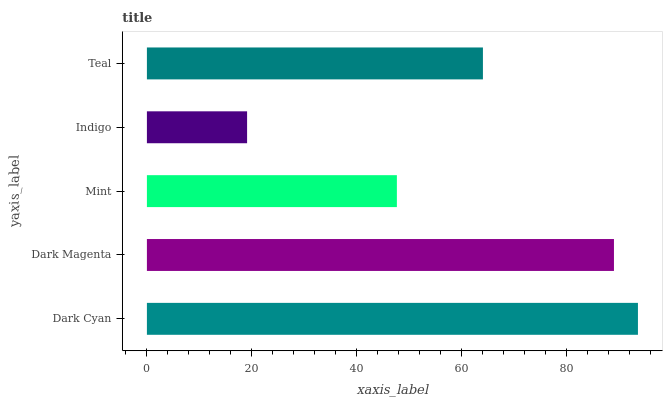Is Indigo the minimum?
Answer yes or no. Yes. Is Dark Cyan the maximum?
Answer yes or no. Yes. Is Dark Magenta the minimum?
Answer yes or no. No. Is Dark Magenta the maximum?
Answer yes or no. No. Is Dark Cyan greater than Dark Magenta?
Answer yes or no. Yes. Is Dark Magenta less than Dark Cyan?
Answer yes or no. Yes. Is Dark Magenta greater than Dark Cyan?
Answer yes or no. No. Is Dark Cyan less than Dark Magenta?
Answer yes or no. No. Is Teal the high median?
Answer yes or no. Yes. Is Teal the low median?
Answer yes or no. Yes. Is Mint the high median?
Answer yes or no. No. Is Dark Magenta the low median?
Answer yes or no. No. 